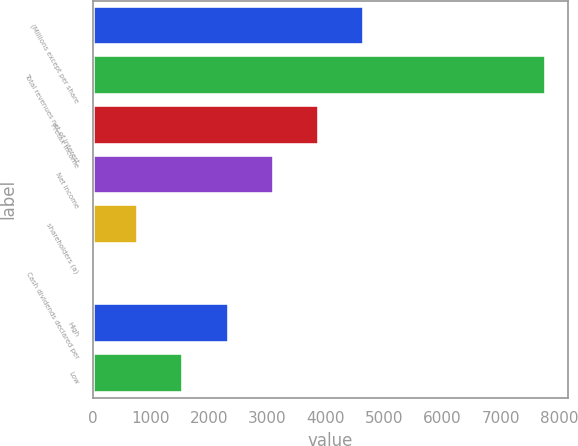<chart> <loc_0><loc_0><loc_500><loc_500><bar_chart><fcel>(Millions except per share<fcel>Total revenues net of interest<fcel>Pretax income<fcel>Net income<fcel>shareholders (a)<fcel>Cash dividends declared per<fcel>High<fcel>Low<nl><fcel>4664.54<fcel>7774<fcel>3887.17<fcel>3109.8<fcel>777.69<fcel>0.32<fcel>2332.43<fcel>1555.06<nl></chart> 